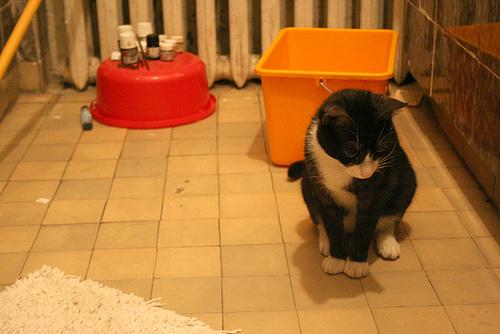Is the floor carpeted or tiled?
Quick response, please. Tiled. What color is the bin?
Give a very brief answer. Orange. What is behind the cat?
Be succinct. Bucket. 